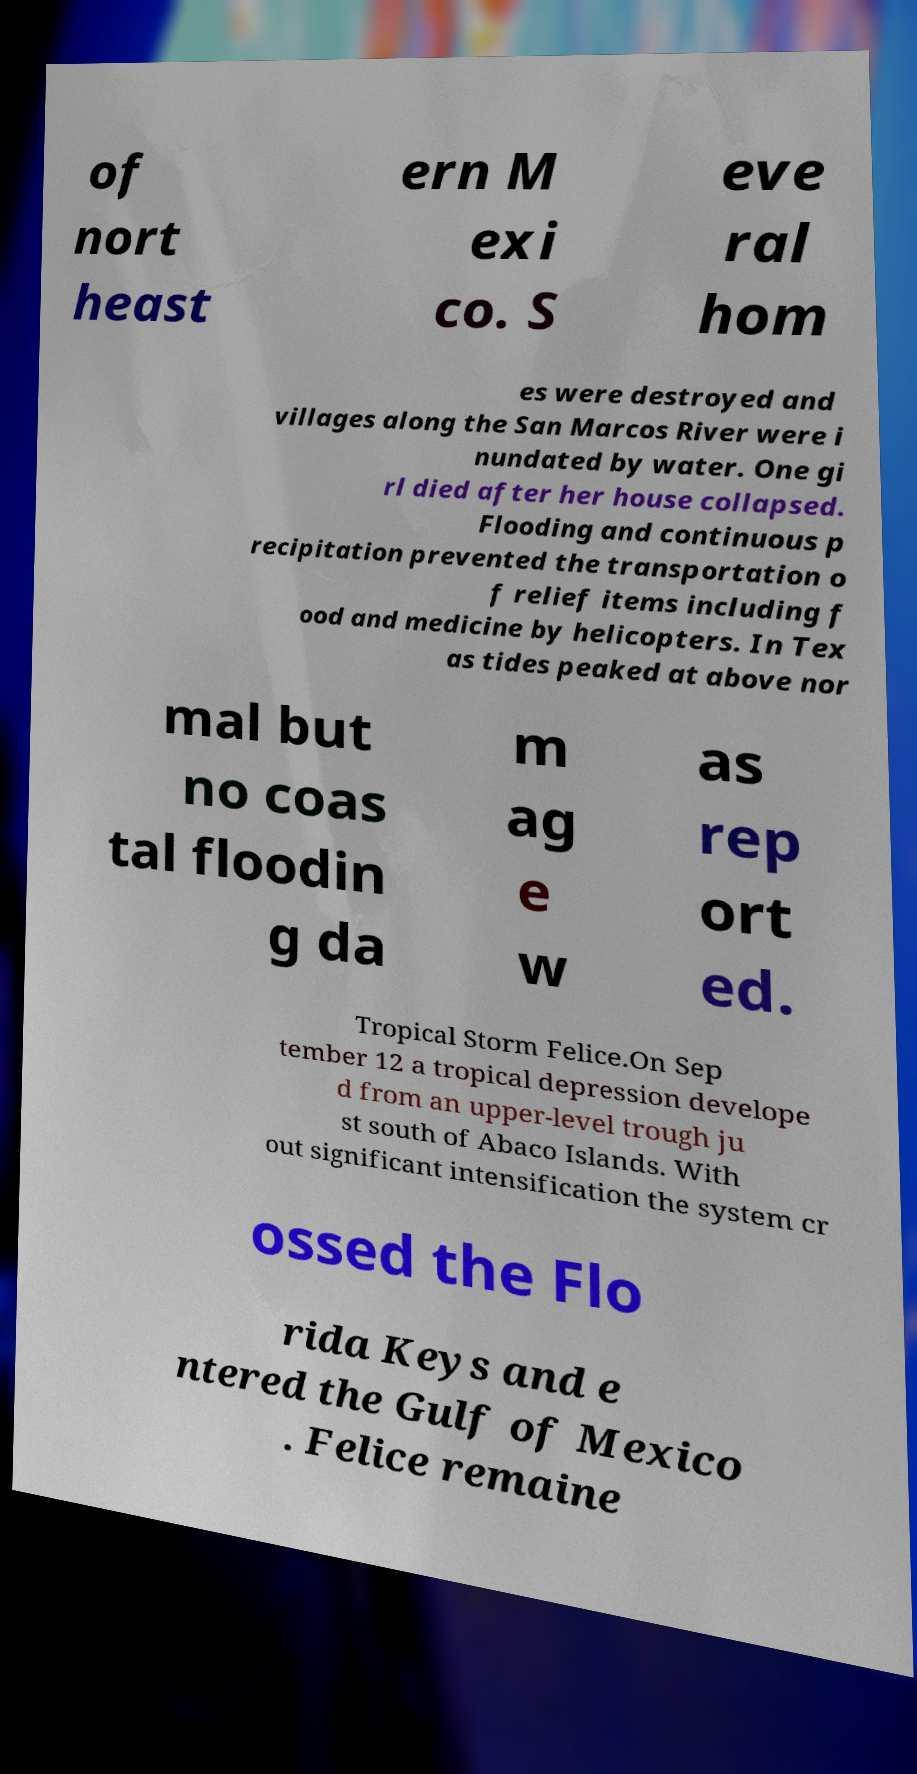Please identify and transcribe the text found in this image. of nort heast ern M exi co. S eve ral hom es were destroyed and villages along the San Marcos River were i nundated by water. One gi rl died after her house collapsed. Flooding and continuous p recipitation prevented the transportation o f relief items including f ood and medicine by helicopters. In Tex as tides peaked at above nor mal but no coas tal floodin g da m ag e w as rep ort ed. Tropical Storm Felice.On Sep tember 12 a tropical depression develope d from an upper-level trough ju st south of Abaco Islands. With out significant intensification the system cr ossed the Flo rida Keys and e ntered the Gulf of Mexico . Felice remaine 